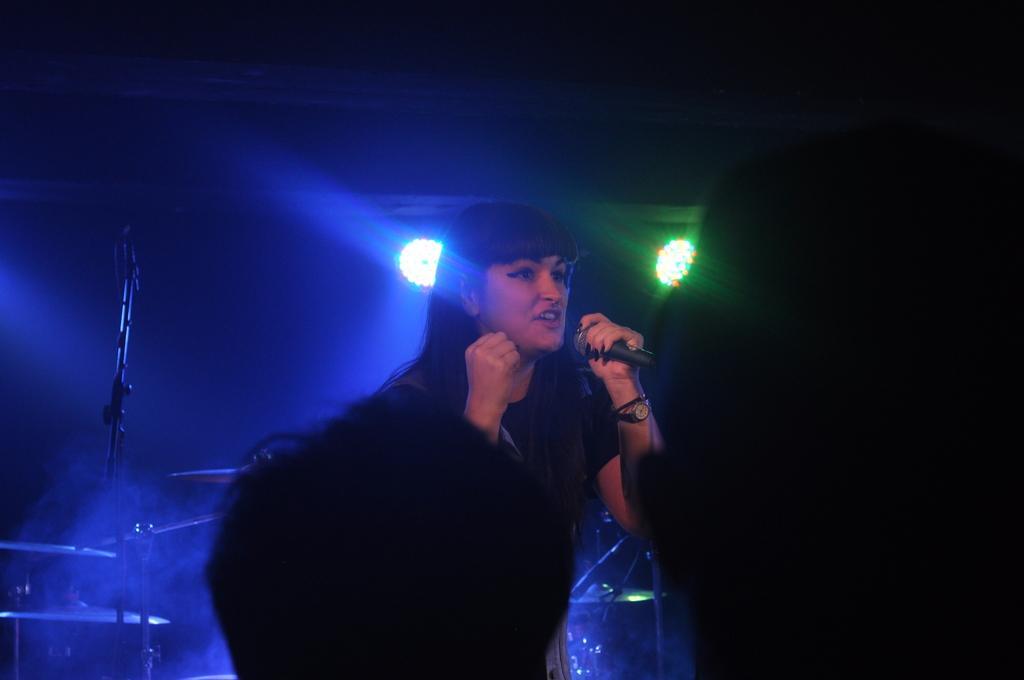Can you describe this image briefly? In this image, we can see a person standing and holding a microphone, we can see the heads of two persons. In the background, we can see the lights. 